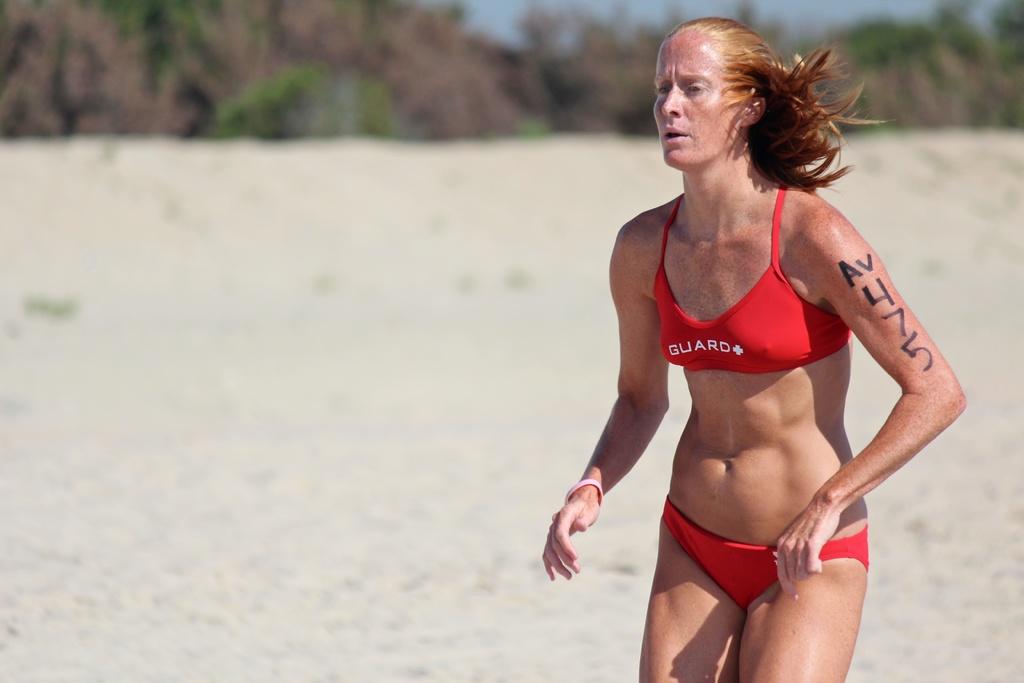What number is on her arm?
Give a very brief answer. 475. What does her shirt say?
Offer a very short reply. Guard. 